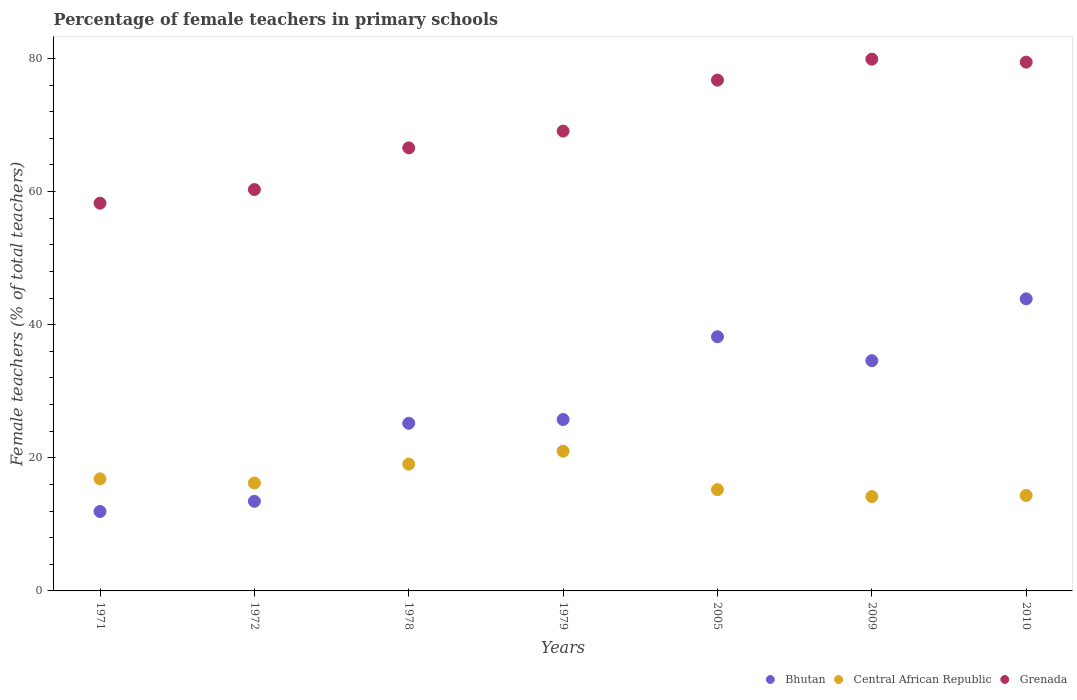Is the number of dotlines equal to the number of legend labels?
Keep it short and to the point. Yes. What is the percentage of female teachers in Grenada in 1978?
Ensure brevity in your answer.  66.56. Across all years, what is the maximum percentage of female teachers in Central African Republic?
Offer a terse response. 20.99. Across all years, what is the minimum percentage of female teachers in Bhutan?
Your answer should be compact. 11.93. In which year was the percentage of female teachers in Bhutan maximum?
Provide a succinct answer. 2010. In which year was the percentage of female teachers in Grenada minimum?
Your answer should be very brief. 1971. What is the total percentage of female teachers in Central African Republic in the graph?
Offer a very short reply. 116.81. What is the difference between the percentage of female teachers in Central African Republic in 2009 and that in 2010?
Provide a succinct answer. -0.16. What is the difference between the percentage of female teachers in Central African Republic in 2009 and the percentage of female teachers in Bhutan in 2010?
Keep it short and to the point. -29.7. What is the average percentage of female teachers in Grenada per year?
Offer a terse response. 70.03. In the year 1978, what is the difference between the percentage of female teachers in Central African Republic and percentage of female teachers in Bhutan?
Provide a short and direct response. -6.13. What is the ratio of the percentage of female teachers in Central African Republic in 1972 to that in 1979?
Provide a succinct answer. 0.77. What is the difference between the highest and the second highest percentage of female teachers in Central African Republic?
Provide a succinct answer. 1.93. What is the difference between the highest and the lowest percentage of female teachers in Central African Republic?
Give a very brief answer. 6.81. Is the sum of the percentage of female teachers in Central African Republic in 1972 and 1979 greater than the maximum percentage of female teachers in Grenada across all years?
Provide a succinct answer. No. Does the percentage of female teachers in Grenada monotonically increase over the years?
Provide a succinct answer. No. How many years are there in the graph?
Ensure brevity in your answer.  7. Are the values on the major ticks of Y-axis written in scientific E-notation?
Provide a short and direct response. No. Does the graph contain any zero values?
Make the answer very short. No. Does the graph contain grids?
Offer a terse response. No. Where does the legend appear in the graph?
Give a very brief answer. Bottom right. What is the title of the graph?
Your response must be concise. Percentage of female teachers in primary schools. What is the label or title of the X-axis?
Ensure brevity in your answer.  Years. What is the label or title of the Y-axis?
Your response must be concise. Female teachers (% of total teachers). What is the Female teachers (% of total teachers) in Bhutan in 1971?
Provide a succinct answer. 11.93. What is the Female teachers (% of total teachers) of Central African Republic in 1971?
Provide a short and direct response. 16.84. What is the Female teachers (% of total teachers) in Grenada in 1971?
Offer a very short reply. 58.25. What is the Female teachers (% of total teachers) of Bhutan in 1972?
Ensure brevity in your answer.  13.46. What is the Female teachers (% of total teachers) of Central African Republic in 1972?
Ensure brevity in your answer.  16.21. What is the Female teachers (% of total teachers) in Grenada in 1972?
Your response must be concise. 60.29. What is the Female teachers (% of total teachers) of Bhutan in 1978?
Ensure brevity in your answer.  25.18. What is the Female teachers (% of total teachers) of Central African Republic in 1978?
Give a very brief answer. 19.05. What is the Female teachers (% of total teachers) in Grenada in 1978?
Offer a terse response. 66.56. What is the Female teachers (% of total teachers) in Bhutan in 1979?
Give a very brief answer. 25.75. What is the Female teachers (% of total teachers) of Central African Republic in 1979?
Offer a very short reply. 20.99. What is the Female teachers (% of total teachers) of Grenada in 1979?
Provide a short and direct response. 69.08. What is the Female teachers (% of total teachers) in Bhutan in 2005?
Your response must be concise. 38.18. What is the Female teachers (% of total teachers) of Central African Republic in 2005?
Your response must be concise. 15.22. What is the Female teachers (% of total teachers) of Grenada in 2005?
Offer a very short reply. 76.74. What is the Female teachers (% of total teachers) in Bhutan in 2009?
Make the answer very short. 34.59. What is the Female teachers (% of total teachers) in Central African Republic in 2009?
Your response must be concise. 14.17. What is the Female teachers (% of total teachers) in Grenada in 2009?
Offer a very short reply. 79.88. What is the Female teachers (% of total teachers) in Bhutan in 2010?
Your answer should be very brief. 43.88. What is the Female teachers (% of total teachers) in Central African Republic in 2010?
Offer a terse response. 14.34. What is the Female teachers (% of total teachers) in Grenada in 2010?
Your answer should be very brief. 79.44. Across all years, what is the maximum Female teachers (% of total teachers) in Bhutan?
Offer a very short reply. 43.88. Across all years, what is the maximum Female teachers (% of total teachers) in Central African Republic?
Keep it short and to the point. 20.99. Across all years, what is the maximum Female teachers (% of total teachers) of Grenada?
Offer a terse response. 79.88. Across all years, what is the minimum Female teachers (% of total teachers) of Bhutan?
Ensure brevity in your answer.  11.93. Across all years, what is the minimum Female teachers (% of total teachers) of Central African Republic?
Provide a short and direct response. 14.17. Across all years, what is the minimum Female teachers (% of total teachers) in Grenada?
Provide a succinct answer. 58.25. What is the total Female teachers (% of total teachers) in Bhutan in the graph?
Give a very brief answer. 192.98. What is the total Female teachers (% of total teachers) of Central African Republic in the graph?
Your answer should be compact. 116.81. What is the total Female teachers (% of total teachers) in Grenada in the graph?
Your answer should be compact. 490.23. What is the difference between the Female teachers (% of total teachers) in Bhutan in 1971 and that in 1972?
Offer a very short reply. -1.53. What is the difference between the Female teachers (% of total teachers) in Central African Republic in 1971 and that in 1972?
Provide a succinct answer. 0.63. What is the difference between the Female teachers (% of total teachers) of Grenada in 1971 and that in 1972?
Make the answer very short. -2.04. What is the difference between the Female teachers (% of total teachers) of Bhutan in 1971 and that in 1978?
Provide a succinct answer. -13.25. What is the difference between the Female teachers (% of total teachers) in Central African Republic in 1971 and that in 1978?
Give a very brief answer. -2.22. What is the difference between the Female teachers (% of total teachers) in Grenada in 1971 and that in 1978?
Your answer should be compact. -8.31. What is the difference between the Female teachers (% of total teachers) in Bhutan in 1971 and that in 1979?
Your answer should be very brief. -13.82. What is the difference between the Female teachers (% of total teachers) in Central African Republic in 1971 and that in 1979?
Your answer should be compact. -4.15. What is the difference between the Female teachers (% of total teachers) in Grenada in 1971 and that in 1979?
Offer a very short reply. -10.83. What is the difference between the Female teachers (% of total teachers) of Bhutan in 1971 and that in 2005?
Make the answer very short. -26.25. What is the difference between the Female teachers (% of total teachers) of Central African Republic in 1971 and that in 2005?
Provide a succinct answer. 1.62. What is the difference between the Female teachers (% of total teachers) in Grenada in 1971 and that in 2005?
Ensure brevity in your answer.  -18.49. What is the difference between the Female teachers (% of total teachers) in Bhutan in 1971 and that in 2009?
Your answer should be compact. -22.66. What is the difference between the Female teachers (% of total teachers) in Central African Republic in 1971 and that in 2009?
Offer a terse response. 2.66. What is the difference between the Female teachers (% of total teachers) in Grenada in 1971 and that in 2009?
Keep it short and to the point. -21.63. What is the difference between the Female teachers (% of total teachers) in Bhutan in 1971 and that in 2010?
Provide a succinct answer. -31.95. What is the difference between the Female teachers (% of total teachers) of Central African Republic in 1971 and that in 2010?
Offer a very short reply. 2.5. What is the difference between the Female teachers (% of total teachers) of Grenada in 1971 and that in 2010?
Offer a very short reply. -21.19. What is the difference between the Female teachers (% of total teachers) of Bhutan in 1972 and that in 1978?
Ensure brevity in your answer.  -11.72. What is the difference between the Female teachers (% of total teachers) of Central African Republic in 1972 and that in 1978?
Your answer should be very brief. -2.84. What is the difference between the Female teachers (% of total teachers) of Grenada in 1972 and that in 1978?
Your answer should be very brief. -6.26. What is the difference between the Female teachers (% of total teachers) of Bhutan in 1972 and that in 1979?
Provide a short and direct response. -12.29. What is the difference between the Female teachers (% of total teachers) in Central African Republic in 1972 and that in 1979?
Your response must be concise. -4.78. What is the difference between the Female teachers (% of total teachers) in Grenada in 1972 and that in 1979?
Provide a short and direct response. -8.78. What is the difference between the Female teachers (% of total teachers) in Bhutan in 1972 and that in 2005?
Make the answer very short. -24.72. What is the difference between the Female teachers (% of total teachers) in Grenada in 1972 and that in 2005?
Offer a terse response. -16.44. What is the difference between the Female teachers (% of total teachers) in Bhutan in 1972 and that in 2009?
Keep it short and to the point. -21.13. What is the difference between the Female teachers (% of total teachers) in Central African Republic in 1972 and that in 2009?
Your response must be concise. 2.03. What is the difference between the Female teachers (% of total teachers) of Grenada in 1972 and that in 2009?
Your answer should be compact. -19.59. What is the difference between the Female teachers (% of total teachers) in Bhutan in 1972 and that in 2010?
Your answer should be compact. -30.41. What is the difference between the Female teachers (% of total teachers) in Central African Republic in 1972 and that in 2010?
Give a very brief answer. 1.87. What is the difference between the Female teachers (% of total teachers) in Grenada in 1972 and that in 2010?
Offer a terse response. -19.14. What is the difference between the Female teachers (% of total teachers) of Bhutan in 1978 and that in 1979?
Give a very brief answer. -0.57. What is the difference between the Female teachers (% of total teachers) of Central African Republic in 1978 and that in 1979?
Provide a short and direct response. -1.93. What is the difference between the Female teachers (% of total teachers) of Grenada in 1978 and that in 1979?
Your answer should be very brief. -2.52. What is the difference between the Female teachers (% of total teachers) of Bhutan in 1978 and that in 2005?
Provide a short and direct response. -13. What is the difference between the Female teachers (% of total teachers) in Central African Republic in 1978 and that in 2005?
Make the answer very short. 3.84. What is the difference between the Female teachers (% of total teachers) of Grenada in 1978 and that in 2005?
Offer a terse response. -10.18. What is the difference between the Female teachers (% of total teachers) in Bhutan in 1978 and that in 2009?
Make the answer very short. -9.4. What is the difference between the Female teachers (% of total teachers) in Central African Republic in 1978 and that in 2009?
Offer a very short reply. 4.88. What is the difference between the Female teachers (% of total teachers) in Grenada in 1978 and that in 2009?
Give a very brief answer. -13.32. What is the difference between the Female teachers (% of total teachers) of Bhutan in 1978 and that in 2010?
Provide a succinct answer. -18.69. What is the difference between the Female teachers (% of total teachers) in Central African Republic in 1978 and that in 2010?
Give a very brief answer. 4.71. What is the difference between the Female teachers (% of total teachers) in Grenada in 1978 and that in 2010?
Provide a short and direct response. -12.88. What is the difference between the Female teachers (% of total teachers) in Bhutan in 1979 and that in 2005?
Offer a terse response. -12.43. What is the difference between the Female teachers (% of total teachers) of Central African Republic in 1979 and that in 2005?
Your answer should be very brief. 5.77. What is the difference between the Female teachers (% of total teachers) in Grenada in 1979 and that in 2005?
Provide a short and direct response. -7.66. What is the difference between the Female teachers (% of total teachers) in Bhutan in 1979 and that in 2009?
Ensure brevity in your answer.  -8.84. What is the difference between the Female teachers (% of total teachers) in Central African Republic in 1979 and that in 2009?
Offer a terse response. 6.81. What is the difference between the Female teachers (% of total teachers) in Grenada in 1979 and that in 2009?
Your answer should be compact. -10.8. What is the difference between the Female teachers (% of total teachers) in Bhutan in 1979 and that in 2010?
Your response must be concise. -18.12. What is the difference between the Female teachers (% of total teachers) of Central African Republic in 1979 and that in 2010?
Keep it short and to the point. 6.65. What is the difference between the Female teachers (% of total teachers) in Grenada in 1979 and that in 2010?
Ensure brevity in your answer.  -10.36. What is the difference between the Female teachers (% of total teachers) of Bhutan in 2005 and that in 2009?
Ensure brevity in your answer.  3.59. What is the difference between the Female teachers (% of total teachers) of Central African Republic in 2005 and that in 2009?
Provide a succinct answer. 1.04. What is the difference between the Female teachers (% of total teachers) of Grenada in 2005 and that in 2009?
Provide a succinct answer. -3.14. What is the difference between the Female teachers (% of total teachers) of Bhutan in 2005 and that in 2010?
Offer a very short reply. -5.69. What is the difference between the Female teachers (% of total teachers) in Central African Republic in 2005 and that in 2010?
Provide a short and direct response. 0.88. What is the difference between the Female teachers (% of total teachers) of Grenada in 2005 and that in 2010?
Give a very brief answer. -2.7. What is the difference between the Female teachers (% of total teachers) of Bhutan in 2009 and that in 2010?
Provide a succinct answer. -9.29. What is the difference between the Female teachers (% of total teachers) of Central African Republic in 2009 and that in 2010?
Provide a succinct answer. -0.16. What is the difference between the Female teachers (% of total teachers) in Grenada in 2009 and that in 2010?
Make the answer very short. 0.44. What is the difference between the Female teachers (% of total teachers) in Bhutan in 1971 and the Female teachers (% of total teachers) in Central African Republic in 1972?
Your response must be concise. -4.28. What is the difference between the Female teachers (% of total teachers) of Bhutan in 1971 and the Female teachers (% of total teachers) of Grenada in 1972?
Offer a terse response. -48.36. What is the difference between the Female teachers (% of total teachers) in Central African Republic in 1971 and the Female teachers (% of total teachers) in Grenada in 1972?
Your response must be concise. -43.46. What is the difference between the Female teachers (% of total teachers) in Bhutan in 1971 and the Female teachers (% of total teachers) in Central African Republic in 1978?
Ensure brevity in your answer.  -7.12. What is the difference between the Female teachers (% of total teachers) of Bhutan in 1971 and the Female teachers (% of total teachers) of Grenada in 1978?
Make the answer very short. -54.63. What is the difference between the Female teachers (% of total teachers) in Central African Republic in 1971 and the Female teachers (% of total teachers) in Grenada in 1978?
Your answer should be compact. -49.72. What is the difference between the Female teachers (% of total teachers) of Bhutan in 1971 and the Female teachers (% of total teachers) of Central African Republic in 1979?
Give a very brief answer. -9.06. What is the difference between the Female teachers (% of total teachers) of Bhutan in 1971 and the Female teachers (% of total teachers) of Grenada in 1979?
Make the answer very short. -57.15. What is the difference between the Female teachers (% of total teachers) of Central African Republic in 1971 and the Female teachers (% of total teachers) of Grenada in 1979?
Your response must be concise. -52.24. What is the difference between the Female teachers (% of total teachers) of Bhutan in 1971 and the Female teachers (% of total teachers) of Central African Republic in 2005?
Make the answer very short. -3.29. What is the difference between the Female teachers (% of total teachers) of Bhutan in 1971 and the Female teachers (% of total teachers) of Grenada in 2005?
Make the answer very short. -64.81. What is the difference between the Female teachers (% of total teachers) in Central African Republic in 1971 and the Female teachers (% of total teachers) in Grenada in 2005?
Provide a succinct answer. -59.9. What is the difference between the Female teachers (% of total teachers) of Bhutan in 1971 and the Female teachers (% of total teachers) of Central African Republic in 2009?
Ensure brevity in your answer.  -2.24. What is the difference between the Female teachers (% of total teachers) of Bhutan in 1971 and the Female teachers (% of total teachers) of Grenada in 2009?
Make the answer very short. -67.95. What is the difference between the Female teachers (% of total teachers) of Central African Republic in 1971 and the Female teachers (% of total teachers) of Grenada in 2009?
Your response must be concise. -63.04. What is the difference between the Female teachers (% of total teachers) of Bhutan in 1971 and the Female teachers (% of total teachers) of Central African Republic in 2010?
Provide a succinct answer. -2.41. What is the difference between the Female teachers (% of total teachers) in Bhutan in 1971 and the Female teachers (% of total teachers) in Grenada in 2010?
Offer a very short reply. -67.51. What is the difference between the Female teachers (% of total teachers) in Central African Republic in 1971 and the Female teachers (% of total teachers) in Grenada in 2010?
Provide a succinct answer. -62.6. What is the difference between the Female teachers (% of total teachers) in Bhutan in 1972 and the Female teachers (% of total teachers) in Central African Republic in 1978?
Ensure brevity in your answer.  -5.59. What is the difference between the Female teachers (% of total teachers) in Bhutan in 1972 and the Female teachers (% of total teachers) in Grenada in 1978?
Provide a short and direct response. -53.1. What is the difference between the Female teachers (% of total teachers) of Central African Republic in 1972 and the Female teachers (% of total teachers) of Grenada in 1978?
Make the answer very short. -50.35. What is the difference between the Female teachers (% of total teachers) of Bhutan in 1972 and the Female teachers (% of total teachers) of Central African Republic in 1979?
Give a very brief answer. -7.52. What is the difference between the Female teachers (% of total teachers) in Bhutan in 1972 and the Female teachers (% of total teachers) in Grenada in 1979?
Provide a succinct answer. -55.62. What is the difference between the Female teachers (% of total teachers) of Central African Republic in 1972 and the Female teachers (% of total teachers) of Grenada in 1979?
Provide a short and direct response. -52.87. What is the difference between the Female teachers (% of total teachers) in Bhutan in 1972 and the Female teachers (% of total teachers) in Central African Republic in 2005?
Offer a terse response. -1.75. What is the difference between the Female teachers (% of total teachers) in Bhutan in 1972 and the Female teachers (% of total teachers) in Grenada in 2005?
Your response must be concise. -63.28. What is the difference between the Female teachers (% of total teachers) of Central African Republic in 1972 and the Female teachers (% of total teachers) of Grenada in 2005?
Offer a very short reply. -60.53. What is the difference between the Female teachers (% of total teachers) in Bhutan in 1972 and the Female teachers (% of total teachers) in Central African Republic in 2009?
Give a very brief answer. -0.71. What is the difference between the Female teachers (% of total teachers) of Bhutan in 1972 and the Female teachers (% of total teachers) of Grenada in 2009?
Provide a succinct answer. -66.42. What is the difference between the Female teachers (% of total teachers) of Central African Republic in 1972 and the Female teachers (% of total teachers) of Grenada in 2009?
Your answer should be very brief. -63.67. What is the difference between the Female teachers (% of total teachers) in Bhutan in 1972 and the Female teachers (% of total teachers) in Central African Republic in 2010?
Provide a short and direct response. -0.88. What is the difference between the Female teachers (% of total teachers) of Bhutan in 1972 and the Female teachers (% of total teachers) of Grenada in 2010?
Offer a terse response. -65.97. What is the difference between the Female teachers (% of total teachers) in Central African Republic in 1972 and the Female teachers (% of total teachers) in Grenada in 2010?
Offer a terse response. -63.23. What is the difference between the Female teachers (% of total teachers) of Bhutan in 1978 and the Female teachers (% of total teachers) of Central African Republic in 1979?
Give a very brief answer. 4.2. What is the difference between the Female teachers (% of total teachers) of Bhutan in 1978 and the Female teachers (% of total teachers) of Grenada in 1979?
Keep it short and to the point. -43.89. What is the difference between the Female teachers (% of total teachers) of Central African Republic in 1978 and the Female teachers (% of total teachers) of Grenada in 1979?
Your answer should be compact. -50.03. What is the difference between the Female teachers (% of total teachers) in Bhutan in 1978 and the Female teachers (% of total teachers) in Central African Republic in 2005?
Your answer should be very brief. 9.97. What is the difference between the Female teachers (% of total teachers) in Bhutan in 1978 and the Female teachers (% of total teachers) in Grenada in 2005?
Your response must be concise. -51.55. What is the difference between the Female teachers (% of total teachers) in Central African Republic in 1978 and the Female teachers (% of total teachers) in Grenada in 2005?
Ensure brevity in your answer.  -57.69. What is the difference between the Female teachers (% of total teachers) in Bhutan in 1978 and the Female teachers (% of total teachers) in Central African Republic in 2009?
Keep it short and to the point. 11.01. What is the difference between the Female teachers (% of total teachers) of Bhutan in 1978 and the Female teachers (% of total teachers) of Grenada in 2009?
Offer a terse response. -54.7. What is the difference between the Female teachers (% of total teachers) of Central African Republic in 1978 and the Female teachers (% of total teachers) of Grenada in 2009?
Provide a short and direct response. -60.83. What is the difference between the Female teachers (% of total teachers) in Bhutan in 1978 and the Female teachers (% of total teachers) in Central African Republic in 2010?
Keep it short and to the point. 10.85. What is the difference between the Female teachers (% of total teachers) in Bhutan in 1978 and the Female teachers (% of total teachers) in Grenada in 2010?
Ensure brevity in your answer.  -54.25. What is the difference between the Female teachers (% of total teachers) of Central African Republic in 1978 and the Female teachers (% of total teachers) of Grenada in 2010?
Provide a short and direct response. -60.38. What is the difference between the Female teachers (% of total teachers) in Bhutan in 1979 and the Female teachers (% of total teachers) in Central African Republic in 2005?
Provide a short and direct response. 10.54. What is the difference between the Female teachers (% of total teachers) in Bhutan in 1979 and the Female teachers (% of total teachers) in Grenada in 2005?
Give a very brief answer. -50.99. What is the difference between the Female teachers (% of total teachers) of Central African Republic in 1979 and the Female teachers (% of total teachers) of Grenada in 2005?
Offer a terse response. -55.75. What is the difference between the Female teachers (% of total teachers) in Bhutan in 1979 and the Female teachers (% of total teachers) in Central African Republic in 2009?
Provide a succinct answer. 11.58. What is the difference between the Female teachers (% of total teachers) of Bhutan in 1979 and the Female teachers (% of total teachers) of Grenada in 2009?
Make the answer very short. -54.13. What is the difference between the Female teachers (% of total teachers) of Central African Republic in 1979 and the Female teachers (% of total teachers) of Grenada in 2009?
Keep it short and to the point. -58.89. What is the difference between the Female teachers (% of total teachers) of Bhutan in 1979 and the Female teachers (% of total teachers) of Central African Republic in 2010?
Give a very brief answer. 11.41. What is the difference between the Female teachers (% of total teachers) in Bhutan in 1979 and the Female teachers (% of total teachers) in Grenada in 2010?
Your answer should be compact. -53.68. What is the difference between the Female teachers (% of total teachers) in Central African Republic in 1979 and the Female teachers (% of total teachers) in Grenada in 2010?
Provide a short and direct response. -58.45. What is the difference between the Female teachers (% of total teachers) in Bhutan in 2005 and the Female teachers (% of total teachers) in Central African Republic in 2009?
Your answer should be very brief. 24.01. What is the difference between the Female teachers (% of total teachers) of Bhutan in 2005 and the Female teachers (% of total teachers) of Grenada in 2009?
Your answer should be very brief. -41.7. What is the difference between the Female teachers (% of total teachers) in Central African Republic in 2005 and the Female teachers (% of total teachers) in Grenada in 2009?
Give a very brief answer. -64.66. What is the difference between the Female teachers (% of total teachers) in Bhutan in 2005 and the Female teachers (% of total teachers) in Central African Republic in 2010?
Offer a very short reply. 23.84. What is the difference between the Female teachers (% of total teachers) in Bhutan in 2005 and the Female teachers (% of total teachers) in Grenada in 2010?
Offer a very short reply. -41.25. What is the difference between the Female teachers (% of total teachers) in Central African Republic in 2005 and the Female teachers (% of total teachers) in Grenada in 2010?
Your answer should be very brief. -64.22. What is the difference between the Female teachers (% of total teachers) of Bhutan in 2009 and the Female teachers (% of total teachers) of Central African Republic in 2010?
Your answer should be very brief. 20.25. What is the difference between the Female teachers (% of total teachers) in Bhutan in 2009 and the Female teachers (% of total teachers) in Grenada in 2010?
Your answer should be very brief. -44.85. What is the difference between the Female teachers (% of total teachers) in Central African Republic in 2009 and the Female teachers (% of total teachers) in Grenada in 2010?
Your answer should be very brief. -65.26. What is the average Female teachers (% of total teachers) of Bhutan per year?
Offer a terse response. 27.57. What is the average Female teachers (% of total teachers) of Central African Republic per year?
Make the answer very short. 16.69. What is the average Female teachers (% of total teachers) of Grenada per year?
Provide a succinct answer. 70.03. In the year 1971, what is the difference between the Female teachers (% of total teachers) of Bhutan and Female teachers (% of total teachers) of Central African Republic?
Offer a terse response. -4.9. In the year 1971, what is the difference between the Female teachers (% of total teachers) in Bhutan and Female teachers (% of total teachers) in Grenada?
Make the answer very short. -46.32. In the year 1971, what is the difference between the Female teachers (% of total teachers) of Central African Republic and Female teachers (% of total teachers) of Grenada?
Offer a very short reply. -41.41. In the year 1972, what is the difference between the Female teachers (% of total teachers) in Bhutan and Female teachers (% of total teachers) in Central African Republic?
Make the answer very short. -2.75. In the year 1972, what is the difference between the Female teachers (% of total teachers) of Bhutan and Female teachers (% of total teachers) of Grenada?
Provide a short and direct response. -46.83. In the year 1972, what is the difference between the Female teachers (% of total teachers) of Central African Republic and Female teachers (% of total teachers) of Grenada?
Your response must be concise. -44.08. In the year 1978, what is the difference between the Female teachers (% of total teachers) in Bhutan and Female teachers (% of total teachers) in Central African Republic?
Your answer should be very brief. 6.13. In the year 1978, what is the difference between the Female teachers (% of total teachers) in Bhutan and Female teachers (% of total teachers) in Grenada?
Keep it short and to the point. -41.37. In the year 1978, what is the difference between the Female teachers (% of total teachers) of Central African Republic and Female teachers (% of total teachers) of Grenada?
Your answer should be very brief. -47.51. In the year 1979, what is the difference between the Female teachers (% of total teachers) of Bhutan and Female teachers (% of total teachers) of Central African Republic?
Your response must be concise. 4.77. In the year 1979, what is the difference between the Female teachers (% of total teachers) in Bhutan and Female teachers (% of total teachers) in Grenada?
Ensure brevity in your answer.  -43.33. In the year 1979, what is the difference between the Female teachers (% of total teachers) of Central African Republic and Female teachers (% of total teachers) of Grenada?
Provide a short and direct response. -48.09. In the year 2005, what is the difference between the Female teachers (% of total teachers) of Bhutan and Female teachers (% of total teachers) of Central African Republic?
Provide a short and direct response. 22.97. In the year 2005, what is the difference between the Female teachers (% of total teachers) of Bhutan and Female teachers (% of total teachers) of Grenada?
Make the answer very short. -38.56. In the year 2005, what is the difference between the Female teachers (% of total teachers) of Central African Republic and Female teachers (% of total teachers) of Grenada?
Offer a very short reply. -61.52. In the year 2009, what is the difference between the Female teachers (% of total teachers) in Bhutan and Female teachers (% of total teachers) in Central African Republic?
Make the answer very short. 20.41. In the year 2009, what is the difference between the Female teachers (% of total teachers) of Bhutan and Female teachers (% of total teachers) of Grenada?
Provide a succinct answer. -45.29. In the year 2009, what is the difference between the Female teachers (% of total teachers) of Central African Republic and Female teachers (% of total teachers) of Grenada?
Your response must be concise. -65.7. In the year 2010, what is the difference between the Female teachers (% of total teachers) of Bhutan and Female teachers (% of total teachers) of Central African Republic?
Offer a terse response. 29.54. In the year 2010, what is the difference between the Female teachers (% of total teachers) of Bhutan and Female teachers (% of total teachers) of Grenada?
Offer a terse response. -35.56. In the year 2010, what is the difference between the Female teachers (% of total teachers) in Central African Republic and Female teachers (% of total teachers) in Grenada?
Your response must be concise. -65.1. What is the ratio of the Female teachers (% of total teachers) in Bhutan in 1971 to that in 1972?
Provide a succinct answer. 0.89. What is the ratio of the Female teachers (% of total teachers) of Central African Republic in 1971 to that in 1972?
Ensure brevity in your answer.  1.04. What is the ratio of the Female teachers (% of total teachers) of Grenada in 1971 to that in 1972?
Make the answer very short. 0.97. What is the ratio of the Female teachers (% of total teachers) in Bhutan in 1971 to that in 1978?
Your response must be concise. 0.47. What is the ratio of the Female teachers (% of total teachers) in Central African Republic in 1971 to that in 1978?
Keep it short and to the point. 0.88. What is the ratio of the Female teachers (% of total teachers) of Grenada in 1971 to that in 1978?
Provide a short and direct response. 0.88. What is the ratio of the Female teachers (% of total teachers) in Bhutan in 1971 to that in 1979?
Offer a terse response. 0.46. What is the ratio of the Female teachers (% of total teachers) in Central African Republic in 1971 to that in 1979?
Provide a short and direct response. 0.8. What is the ratio of the Female teachers (% of total teachers) of Grenada in 1971 to that in 1979?
Provide a short and direct response. 0.84. What is the ratio of the Female teachers (% of total teachers) in Bhutan in 1971 to that in 2005?
Your answer should be very brief. 0.31. What is the ratio of the Female teachers (% of total teachers) of Central African Republic in 1971 to that in 2005?
Your answer should be compact. 1.11. What is the ratio of the Female teachers (% of total teachers) in Grenada in 1971 to that in 2005?
Offer a terse response. 0.76. What is the ratio of the Female teachers (% of total teachers) of Bhutan in 1971 to that in 2009?
Keep it short and to the point. 0.34. What is the ratio of the Female teachers (% of total teachers) in Central African Republic in 1971 to that in 2009?
Ensure brevity in your answer.  1.19. What is the ratio of the Female teachers (% of total teachers) of Grenada in 1971 to that in 2009?
Make the answer very short. 0.73. What is the ratio of the Female teachers (% of total teachers) of Bhutan in 1971 to that in 2010?
Offer a very short reply. 0.27. What is the ratio of the Female teachers (% of total teachers) of Central African Republic in 1971 to that in 2010?
Offer a very short reply. 1.17. What is the ratio of the Female teachers (% of total teachers) in Grenada in 1971 to that in 2010?
Keep it short and to the point. 0.73. What is the ratio of the Female teachers (% of total teachers) of Bhutan in 1972 to that in 1978?
Your answer should be very brief. 0.53. What is the ratio of the Female teachers (% of total teachers) in Central African Republic in 1972 to that in 1978?
Your answer should be compact. 0.85. What is the ratio of the Female teachers (% of total teachers) in Grenada in 1972 to that in 1978?
Provide a short and direct response. 0.91. What is the ratio of the Female teachers (% of total teachers) of Bhutan in 1972 to that in 1979?
Keep it short and to the point. 0.52. What is the ratio of the Female teachers (% of total teachers) of Central African Republic in 1972 to that in 1979?
Offer a terse response. 0.77. What is the ratio of the Female teachers (% of total teachers) in Grenada in 1972 to that in 1979?
Keep it short and to the point. 0.87. What is the ratio of the Female teachers (% of total teachers) in Bhutan in 1972 to that in 2005?
Ensure brevity in your answer.  0.35. What is the ratio of the Female teachers (% of total teachers) in Central African Republic in 1972 to that in 2005?
Your response must be concise. 1.07. What is the ratio of the Female teachers (% of total teachers) in Grenada in 1972 to that in 2005?
Provide a short and direct response. 0.79. What is the ratio of the Female teachers (% of total teachers) of Bhutan in 1972 to that in 2009?
Offer a terse response. 0.39. What is the ratio of the Female teachers (% of total teachers) of Central African Republic in 1972 to that in 2009?
Your answer should be compact. 1.14. What is the ratio of the Female teachers (% of total teachers) in Grenada in 1972 to that in 2009?
Offer a terse response. 0.75. What is the ratio of the Female teachers (% of total teachers) in Bhutan in 1972 to that in 2010?
Provide a short and direct response. 0.31. What is the ratio of the Female teachers (% of total teachers) of Central African Republic in 1972 to that in 2010?
Offer a terse response. 1.13. What is the ratio of the Female teachers (% of total teachers) of Grenada in 1972 to that in 2010?
Offer a terse response. 0.76. What is the ratio of the Female teachers (% of total teachers) in Bhutan in 1978 to that in 1979?
Provide a short and direct response. 0.98. What is the ratio of the Female teachers (% of total teachers) of Central African Republic in 1978 to that in 1979?
Give a very brief answer. 0.91. What is the ratio of the Female teachers (% of total teachers) of Grenada in 1978 to that in 1979?
Provide a short and direct response. 0.96. What is the ratio of the Female teachers (% of total teachers) in Bhutan in 1978 to that in 2005?
Offer a very short reply. 0.66. What is the ratio of the Female teachers (% of total teachers) in Central African Republic in 1978 to that in 2005?
Keep it short and to the point. 1.25. What is the ratio of the Female teachers (% of total teachers) of Grenada in 1978 to that in 2005?
Keep it short and to the point. 0.87. What is the ratio of the Female teachers (% of total teachers) of Bhutan in 1978 to that in 2009?
Give a very brief answer. 0.73. What is the ratio of the Female teachers (% of total teachers) of Central African Republic in 1978 to that in 2009?
Offer a very short reply. 1.34. What is the ratio of the Female teachers (% of total teachers) of Grenada in 1978 to that in 2009?
Offer a very short reply. 0.83. What is the ratio of the Female teachers (% of total teachers) of Bhutan in 1978 to that in 2010?
Your response must be concise. 0.57. What is the ratio of the Female teachers (% of total teachers) of Central African Republic in 1978 to that in 2010?
Provide a short and direct response. 1.33. What is the ratio of the Female teachers (% of total teachers) of Grenada in 1978 to that in 2010?
Ensure brevity in your answer.  0.84. What is the ratio of the Female teachers (% of total teachers) in Bhutan in 1979 to that in 2005?
Your response must be concise. 0.67. What is the ratio of the Female teachers (% of total teachers) in Central African Republic in 1979 to that in 2005?
Your response must be concise. 1.38. What is the ratio of the Female teachers (% of total teachers) of Grenada in 1979 to that in 2005?
Give a very brief answer. 0.9. What is the ratio of the Female teachers (% of total teachers) in Bhutan in 1979 to that in 2009?
Your answer should be compact. 0.74. What is the ratio of the Female teachers (% of total teachers) of Central African Republic in 1979 to that in 2009?
Your response must be concise. 1.48. What is the ratio of the Female teachers (% of total teachers) in Grenada in 1979 to that in 2009?
Offer a very short reply. 0.86. What is the ratio of the Female teachers (% of total teachers) in Bhutan in 1979 to that in 2010?
Give a very brief answer. 0.59. What is the ratio of the Female teachers (% of total teachers) of Central African Republic in 1979 to that in 2010?
Keep it short and to the point. 1.46. What is the ratio of the Female teachers (% of total teachers) of Grenada in 1979 to that in 2010?
Your answer should be very brief. 0.87. What is the ratio of the Female teachers (% of total teachers) of Bhutan in 2005 to that in 2009?
Ensure brevity in your answer.  1.1. What is the ratio of the Female teachers (% of total teachers) of Central African Republic in 2005 to that in 2009?
Your response must be concise. 1.07. What is the ratio of the Female teachers (% of total teachers) of Grenada in 2005 to that in 2009?
Your answer should be very brief. 0.96. What is the ratio of the Female teachers (% of total teachers) of Bhutan in 2005 to that in 2010?
Give a very brief answer. 0.87. What is the ratio of the Female teachers (% of total teachers) of Central African Republic in 2005 to that in 2010?
Ensure brevity in your answer.  1.06. What is the ratio of the Female teachers (% of total teachers) in Grenada in 2005 to that in 2010?
Your answer should be compact. 0.97. What is the ratio of the Female teachers (% of total teachers) in Bhutan in 2009 to that in 2010?
Provide a succinct answer. 0.79. What is the ratio of the Female teachers (% of total teachers) in Grenada in 2009 to that in 2010?
Keep it short and to the point. 1.01. What is the difference between the highest and the second highest Female teachers (% of total teachers) in Bhutan?
Offer a terse response. 5.69. What is the difference between the highest and the second highest Female teachers (% of total teachers) of Central African Republic?
Keep it short and to the point. 1.93. What is the difference between the highest and the second highest Female teachers (% of total teachers) in Grenada?
Make the answer very short. 0.44. What is the difference between the highest and the lowest Female teachers (% of total teachers) of Bhutan?
Your answer should be very brief. 31.95. What is the difference between the highest and the lowest Female teachers (% of total teachers) of Central African Republic?
Offer a very short reply. 6.81. What is the difference between the highest and the lowest Female teachers (% of total teachers) of Grenada?
Your answer should be compact. 21.63. 